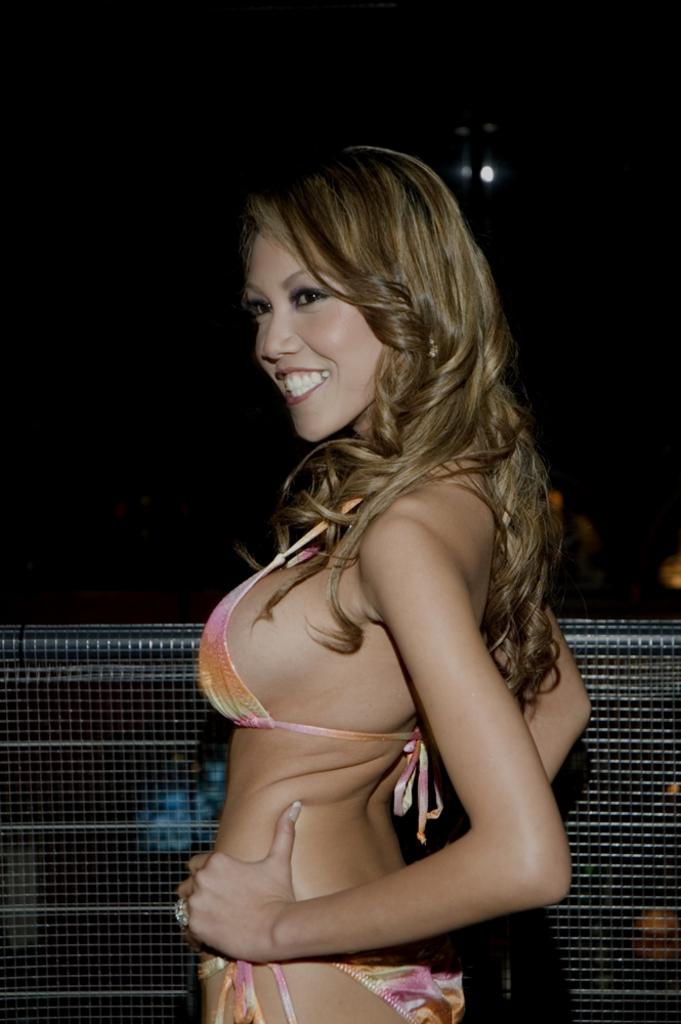What is the main subject of the image? There is a person standing in the image. What other objects or features can be seen in the image? There is a fence in the image, but it is truncated, and there is a light in the image. How would you describe the overall lighting in the image? The background of the image is dark. How many books can be seen on the person's head in the image? There are no books visible in the image; the main subject is a person standing. 